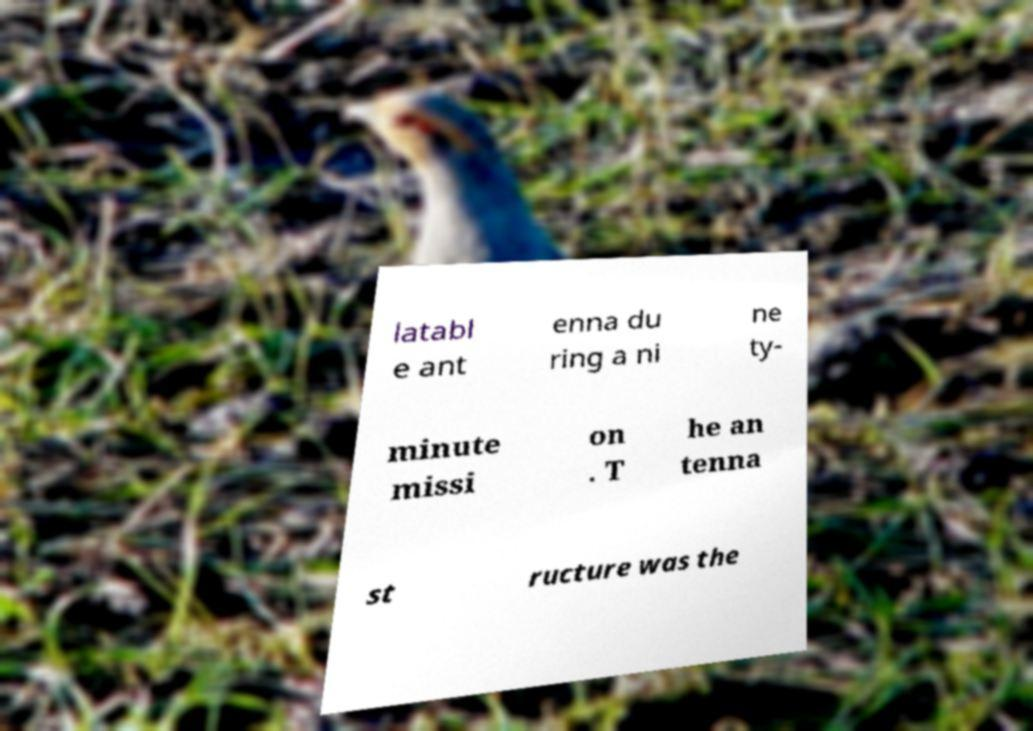What messages or text are displayed in this image? I need them in a readable, typed format. latabl e ant enna du ring a ni ne ty- minute missi on . T he an tenna st ructure was the 